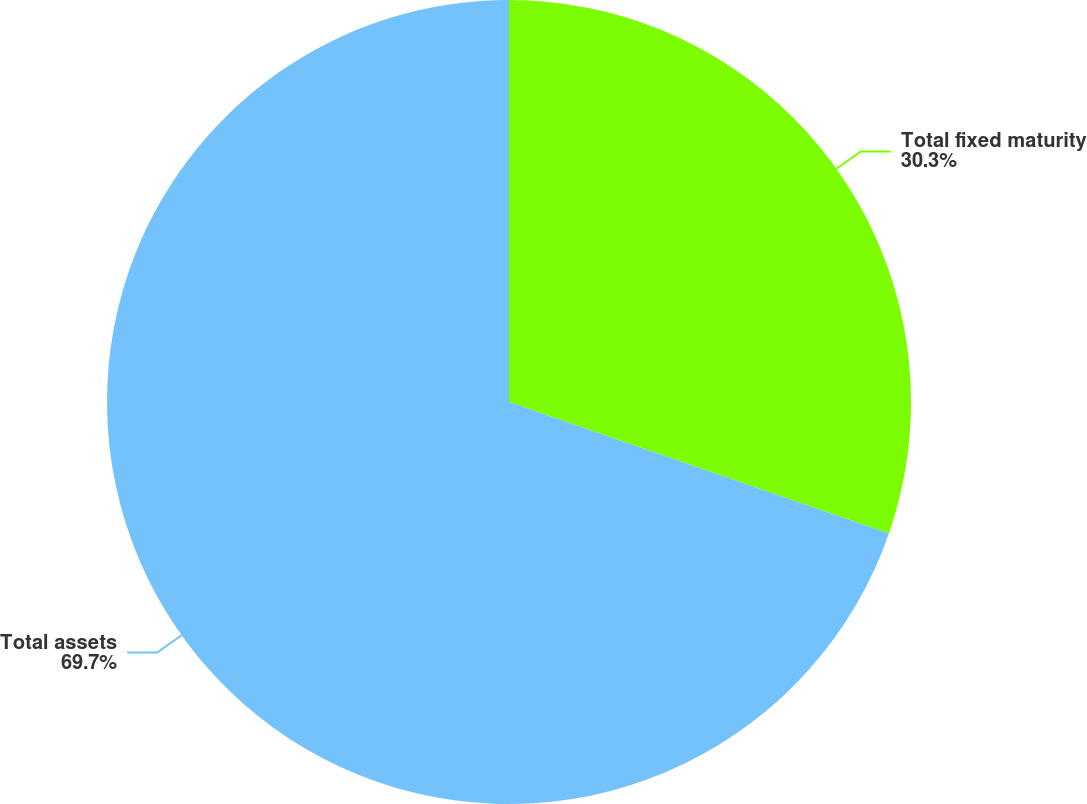Convert chart. <chart><loc_0><loc_0><loc_500><loc_500><pie_chart><fcel>Total fixed maturity<fcel>Total assets<nl><fcel>30.3%<fcel>69.7%<nl></chart> 